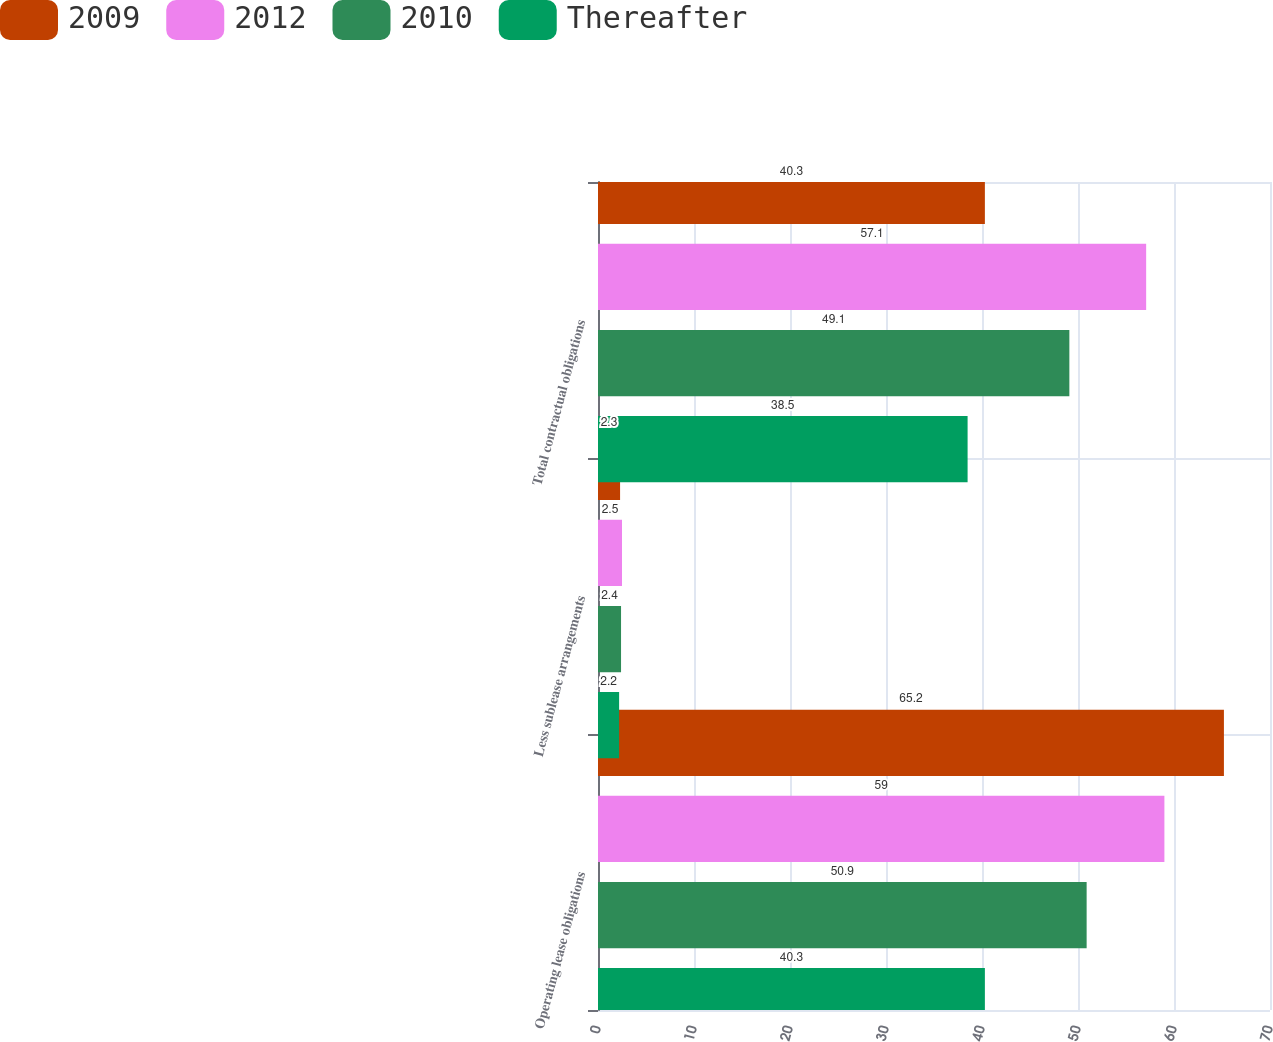<chart> <loc_0><loc_0><loc_500><loc_500><stacked_bar_chart><ecel><fcel>Operating lease obligations<fcel>Less sublease arrangements<fcel>Total contractual obligations<nl><fcel>2009<fcel>65.2<fcel>2.3<fcel>40.3<nl><fcel>2012<fcel>59<fcel>2.5<fcel>57.1<nl><fcel>2010<fcel>50.9<fcel>2.4<fcel>49.1<nl><fcel>Thereafter<fcel>40.3<fcel>2.2<fcel>38.5<nl></chart> 